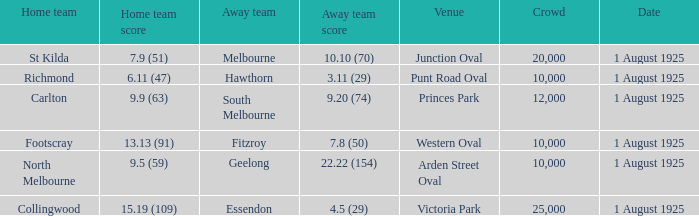Which team plays home at Princes Park? Carlton. 